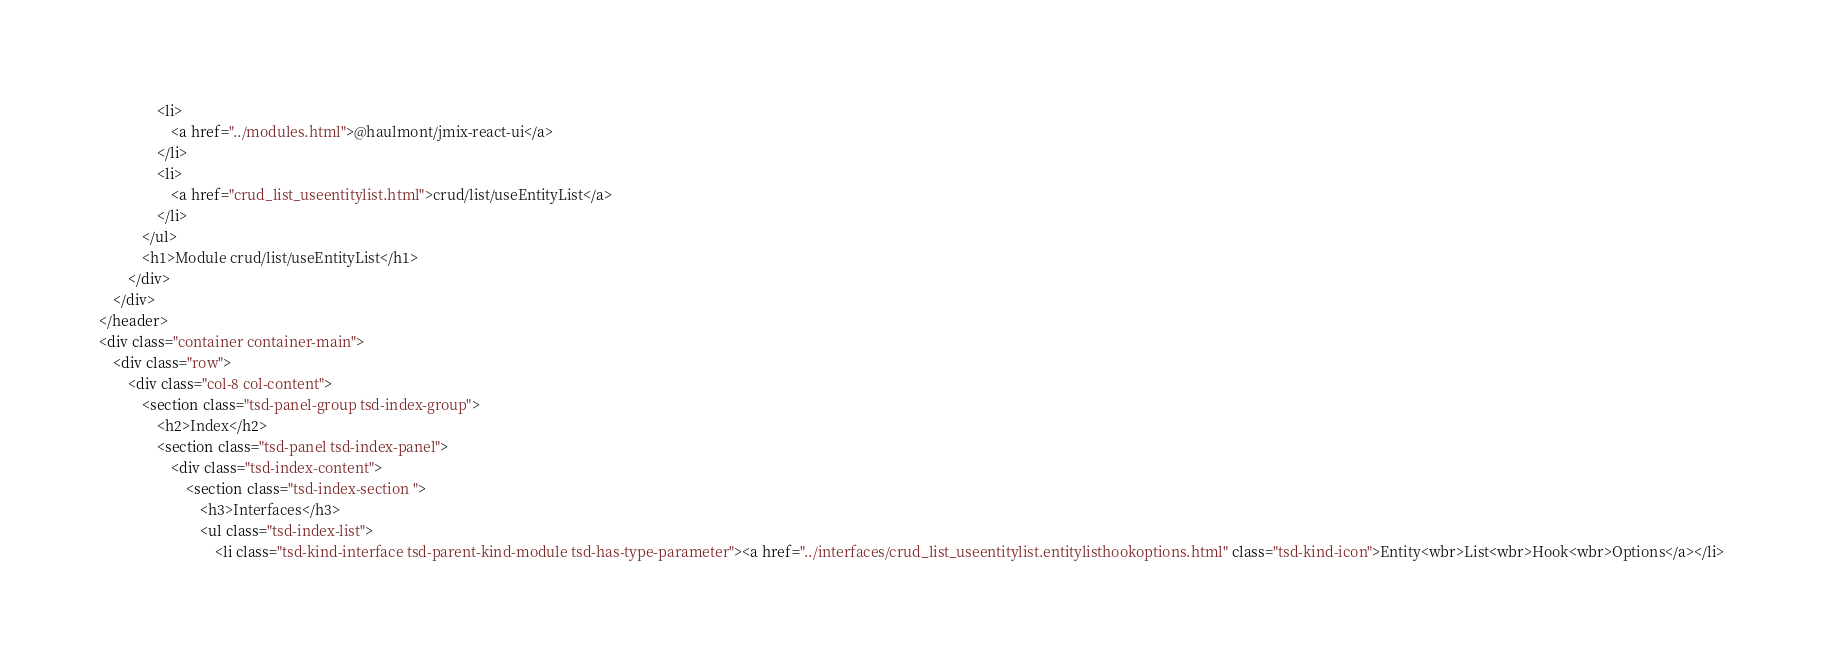Convert code to text. <code><loc_0><loc_0><loc_500><loc_500><_HTML_>				<li>
					<a href="../modules.html">@haulmont/jmix-react-ui</a>
				</li>
				<li>
					<a href="crud_list_useentitylist.html">crud/list/useEntityList</a>
				</li>
			</ul>
			<h1>Module crud/list/useEntityList</h1>
		</div>
	</div>
</header>
<div class="container container-main">
	<div class="row">
		<div class="col-8 col-content">
			<section class="tsd-panel-group tsd-index-group">
				<h2>Index</h2>
				<section class="tsd-panel tsd-index-panel">
					<div class="tsd-index-content">
						<section class="tsd-index-section ">
							<h3>Interfaces</h3>
							<ul class="tsd-index-list">
								<li class="tsd-kind-interface tsd-parent-kind-module tsd-has-type-parameter"><a href="../interfaces/crud_list_useentitylist.entitylisthookoptions.html" class="tsd-kind-icon">Entity<wbr>List<wbr>Hook<wbr>Options</a></li></code> 